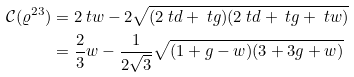Convert formula to latex. <formula><loc_0><loc_0><loc_500><loc_500>\mathcal { C } ( \varrho ^ { 2 3 } ) & = 2 \ t w - 2 \sqrt { ( 2 \ t d + \ t g ) ( 2 \ t d + \ t g + \ t w ) } \\ & = \frac { 2 } { 3 } w - \frac { 1 } { 2 \sqrt { 3 } } \sqrt { ( 1 + g - w ) ( 3 + 3 g + w ) }</formula> 